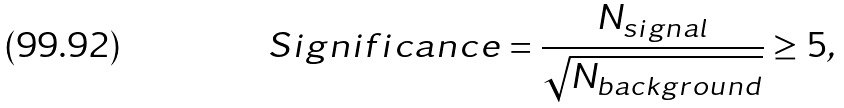<formula> <loc_0><loc_0><loc_500><loc_500>S i g n i f i c a n c e = \frac { N _ { s i g n a l } } { \sqrt { N _ { b a c k g r o u n d } } } \geq 5 ,</formula> 